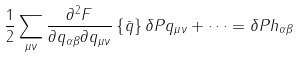<formula> <loc_0><loc_0><loc_500><loc_500>\frac { 1 } { 2 } \sum _ { \mu \nu } \frac { \partial ^ { 2 } F } { \partial q _ { \alpha \beta } \partial q _ { \mu \nu } } \left \{ \bar { q } \right \} \delta P q _ { \mu \nu } + \dots = \delta P h _ { \alpha \beta }</formula> 